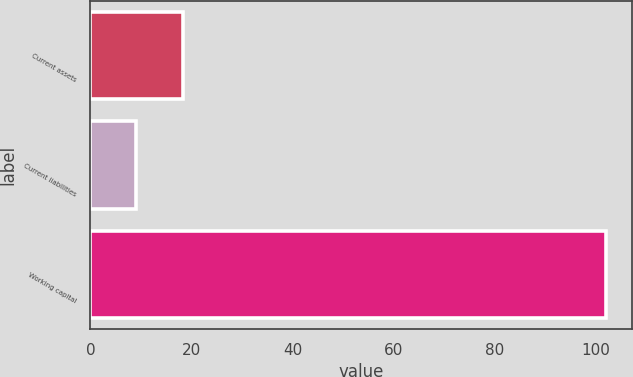Convert chart to OTSL. <chart><loc_0><loc_0><loc_500><loc_500><bar_chart><fcel>Current assets<fcel>Current liabilities<fcel>Working capital<nl><fcel>18.3<fcel>9<fcel>102<nl></chart> 